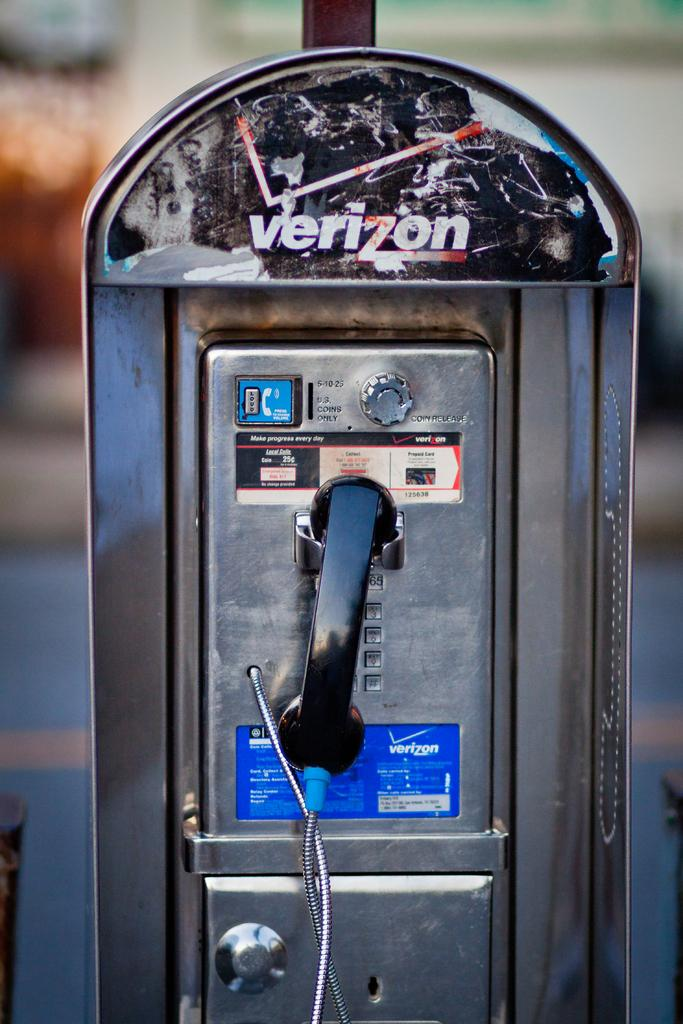What object is located in the middle of the image? There is a telephone in the middle of the image. Can you describe the background of the image? The background of the image is blurry. What type of cover is on the telephone in the image? There is no cover on the telephone in the image. What sound does the telephone make in the image? The image does not depict any sound, including bells, as it is a still image. What type of chain is attached to the telephone in the image? There is no chain attached to the telephone in the image. 